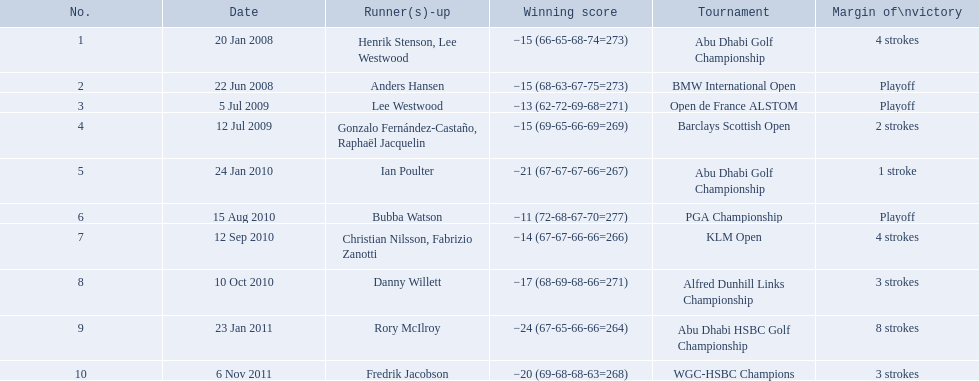How many strokes were in the klm open by martin kaymer? 4 strokes. How many strokes were in the abu dhabi golf championship? 4 strokes. How many more strokes were there in the klm than the barclays open? 2 strokes. 